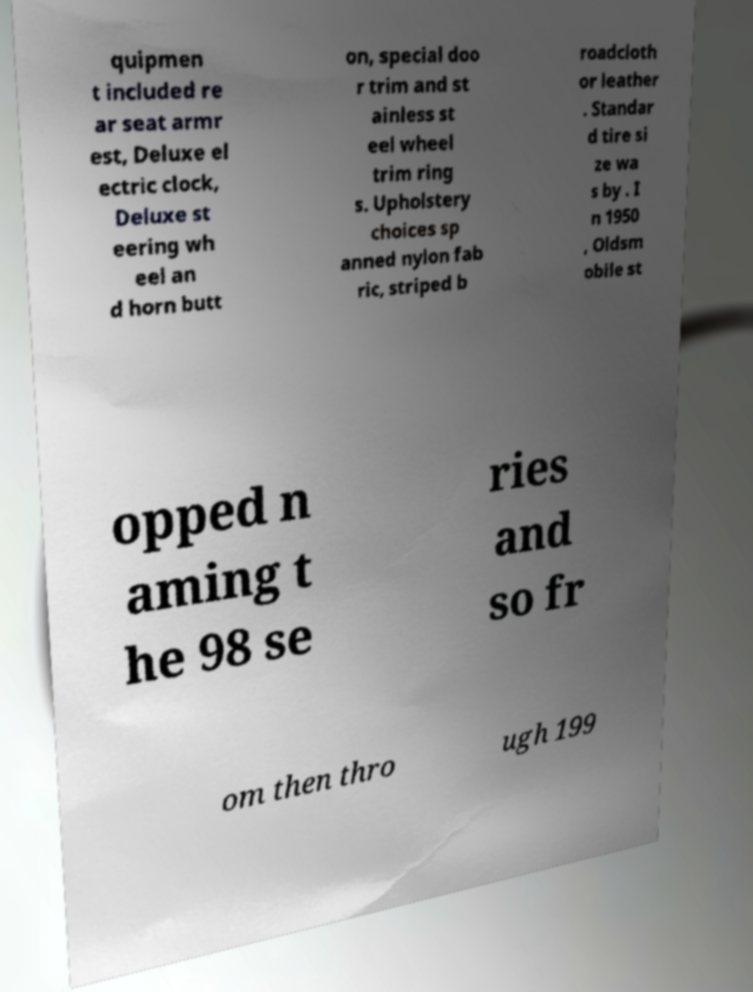There's text embedded in this image that I need extracted. Can you transcribe it verbatim? quipmen t included re ar seat armr est, Deluxe el ectric clock, Deluxe st eering wh eel an d horn butt on, special doo r trim and st ainless st eel wheel trim ring s. Upholstery choices sp anned nylon fab ric, striped b roadcloth or leather . Standar d tire si ze wa s by . I n 1950 , Oldsm obile st opped n aming t he 98 se ries and so fr om then thro ugh 199 